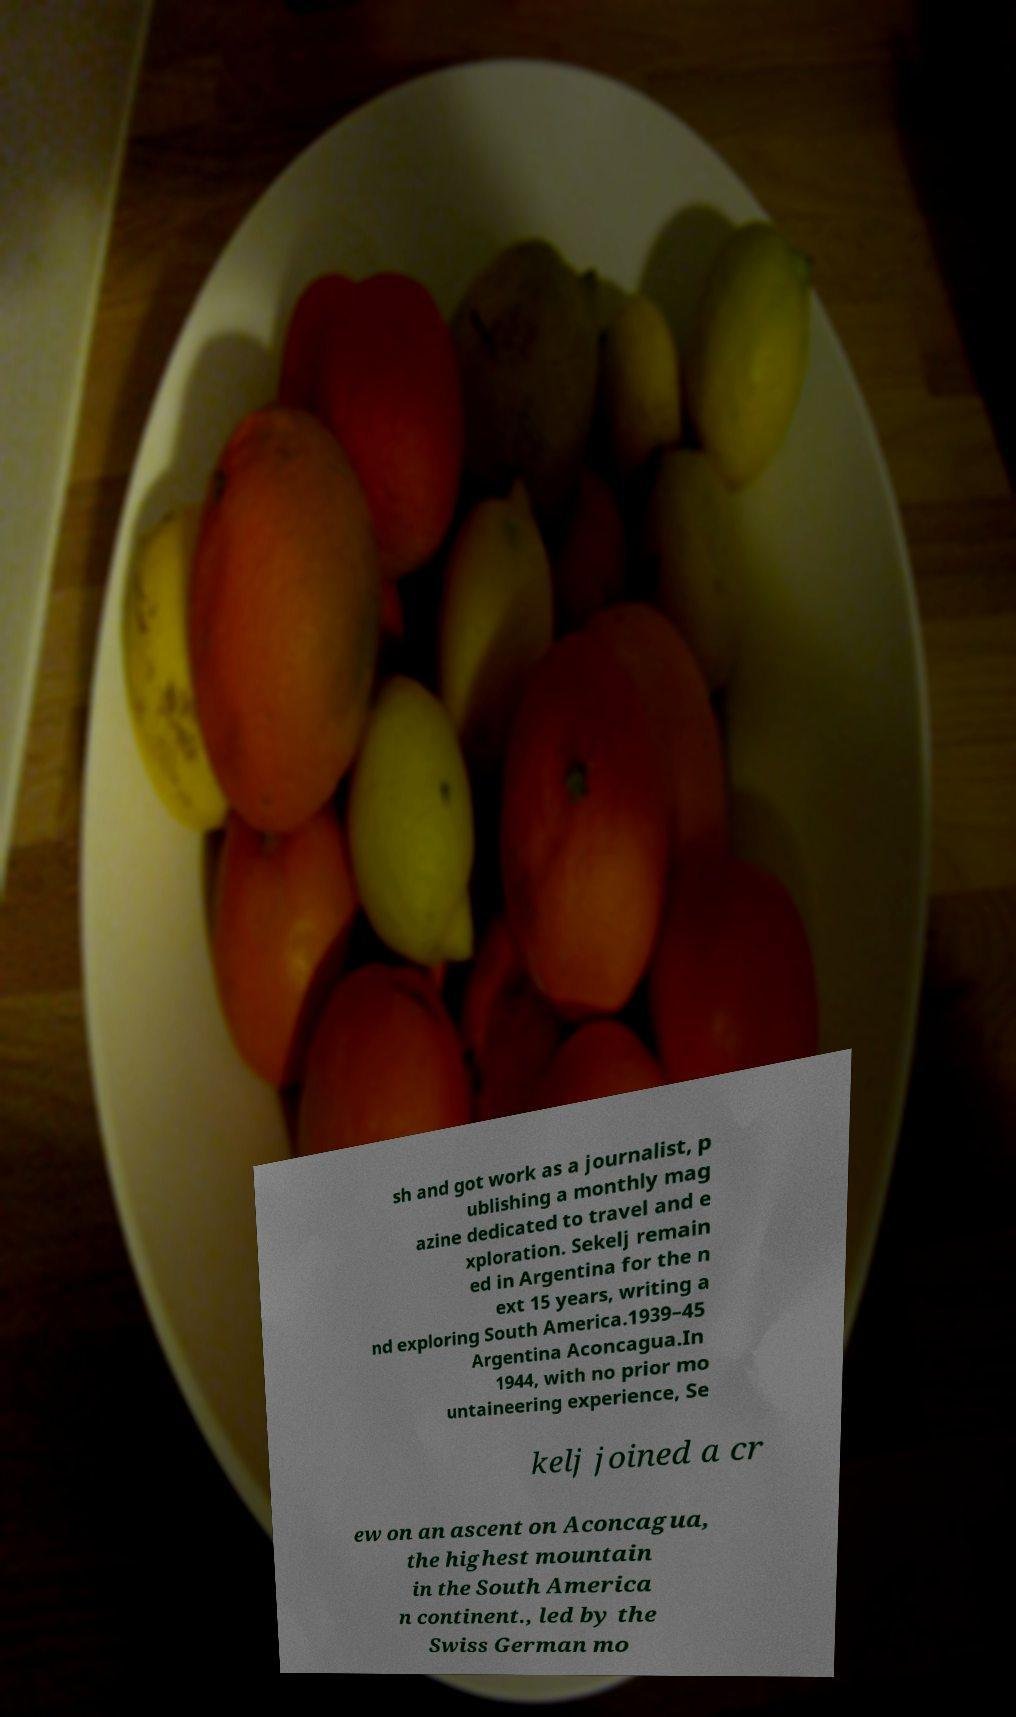I need the written content from this picture converted into text. Can you do that? sh and got work as a journalist, p ublishing a monthly mag azine dedicated to travel and e xploration. Sekelj remain ed in Argentina for the n ext 15 years, writing a nd exploring South America.1939–45 Argentina Aconcagua.In 1944, with no prior mo untaineering experience, Se kelj joined a cr ew on an ascent on Aconcagua, the highest mountain in the South America n continent., led by the Swiss German mo 